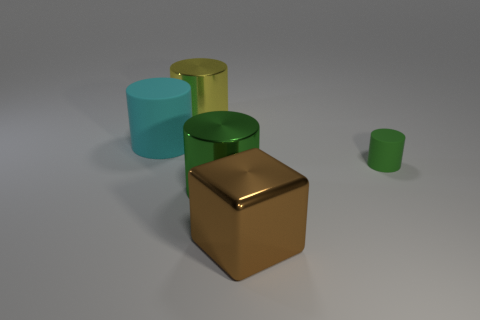What number of other brown shiny things have the same size as the brown shiny object?
Provide a short and direct response. 0. There is a green cylinder on the left side of the tiny green thing; is its size the same as the metallic cylinder that is behind the tiny matte cylinder?
Your response must be concise. Yes. How many objects are either purple matte cylinders or large brown blocks on the right side of the large cyan rubber cylinder?
Keep it short and to the point. 1. The big block is what color?
Provide a succinct answer. Brown. There is a thing to the left of the metallic object behind the big metal cylinder in front of the small cylinder; what is it made of?
Offer a very short reply. Rubber. The cylinder that is made of the same material as the small green thing is what size?
Your response must be concise. Large. Is there another large cube that has the same color as the metallic block?
Your answer should be very brief. No. Does the shiny block have the same size as the cylinder that is to the right of the green shiny cylinder?
Provide a short and direct response. No. What number of big green metal cylinders are behind the matte thing in front of the rubber thing left of the large brown block?
Ensure brevity in your answer.  0. The thing that is the same color as the tiny cylinder is what size?
Provide a succinct answer. Large. 